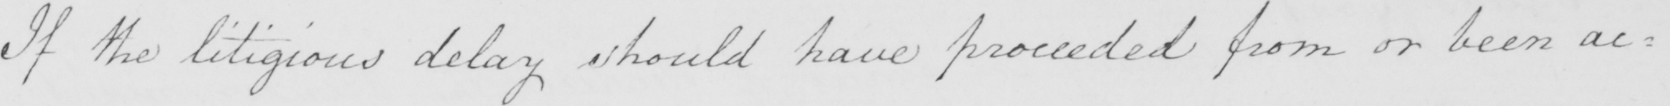What does this handwritten line say? If the litigious delay should have proceeded from or been ac= 